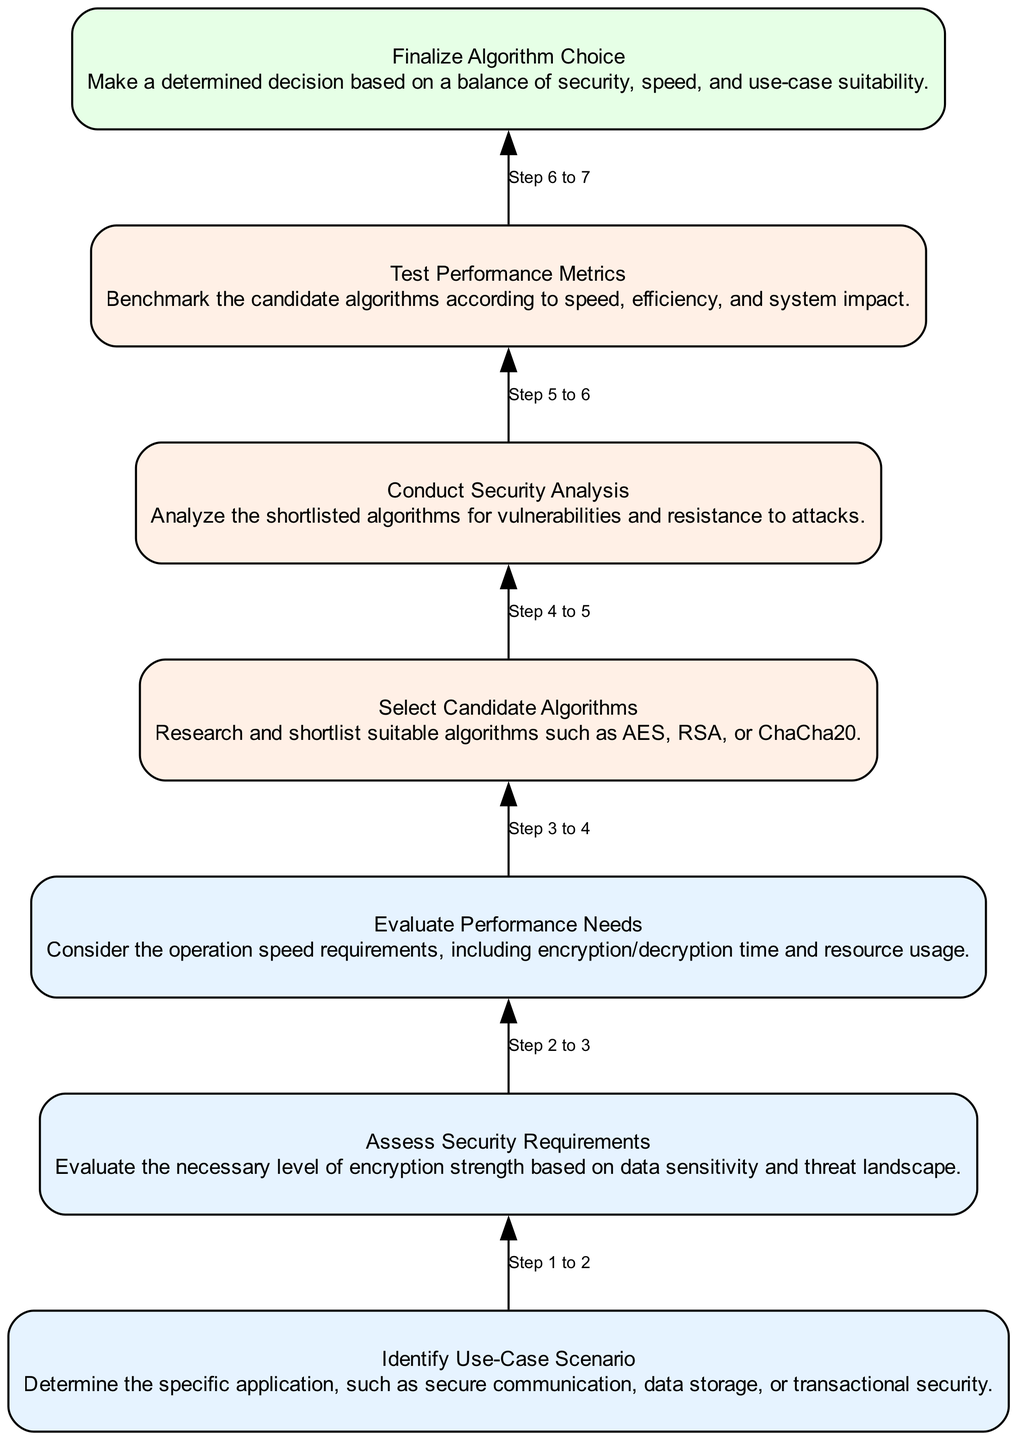What is the first step in the encryption algorithm selection process? The diagram lists "Identify Use-Case Scenario" as the initial step. It is positioned at the bottom of the chart, clearly indicating it is the starting point for the process.
Answer: Identify Use-Case Scenario How many nodes are in the flow chart? By counting each distinct step in the chart, there are a total of seven nodes representing different stages in the encryption algorithm selection process.
Answer: 7 What does the fourth node in the diagram focus on? The fourth node is labeled "Select Candidate Algorithms" and emphasizes the need to research and shortlist suitable algorithms for encryption.
Answer: Select Candidate Algorithms Which node involves assessing vulnerabilities? The fifth node, "Conduct Security Analysis," includes an evaluation of the shortlisted algorithms to identify any vulnerabilities they may have.
Answer: Conduct Security Analysis What is the final decision in the process? The last step in the process is "Finalize Algorithm Choice," which determines the optimal algorithm considering security, speed, and use-case suitability.
Answer: Finalize Algorithm Choice How does "Evaluate Performance Needs" connect to the first step? The second node, "Assess Security Requirements," takes input from the first step to ensure that the chosen use-case scenario is aligned with the performance requirements being evaluated.
Answer: Indirectly, through assessing needs Which step comes immediately after testing algorithms? Following the "Test Performance Metrics" which is the sixth step, the next step is "Finalize Algorithm Choice," marking the end of the selection process.
Answer: Finalize Algorithm Choice What is the general flow direction of the diagram? The diagram flows upward from the initial identification of the use-case scenario to the ultimate finalization of the algorithm choice, adhering to the bottom-up structure.
Answer: Upward 